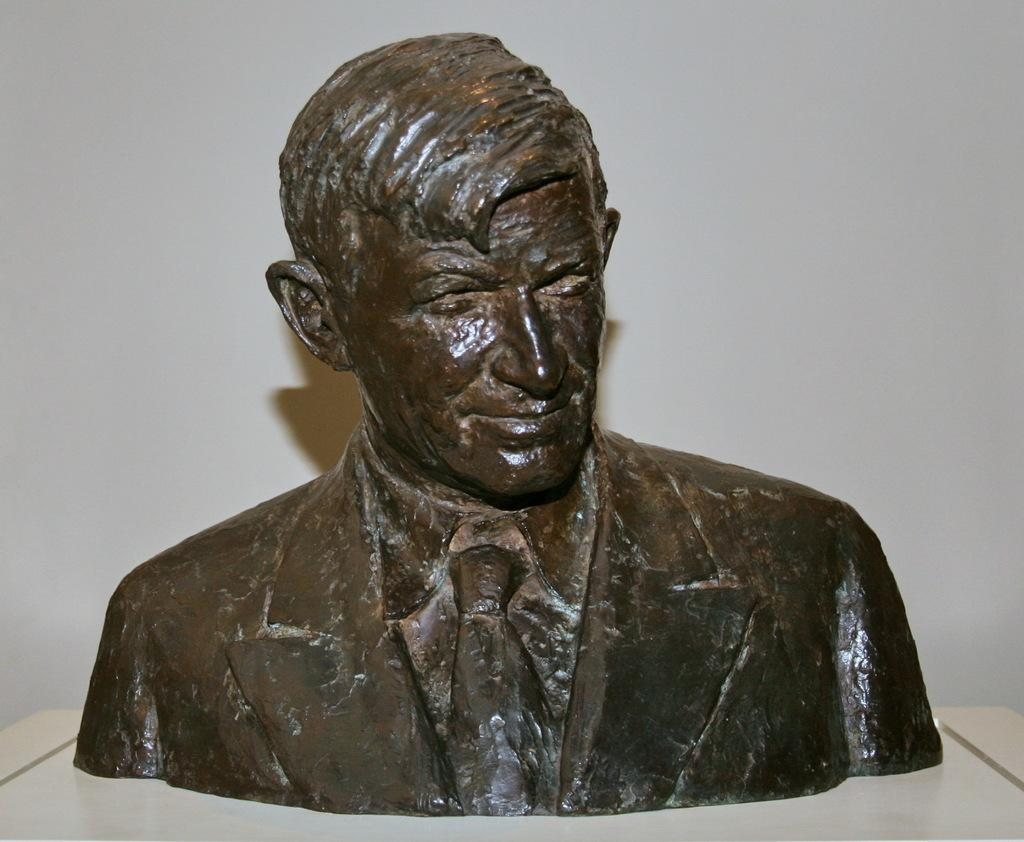What is the main subject of the image? There is a small statue of a man in the image. What can be seen in the background of the image? There is a white wall in the background of the image. What color is the man's thought in the image? There is no indication of the man's thoughts in the image, and therefore no color can be determined. 